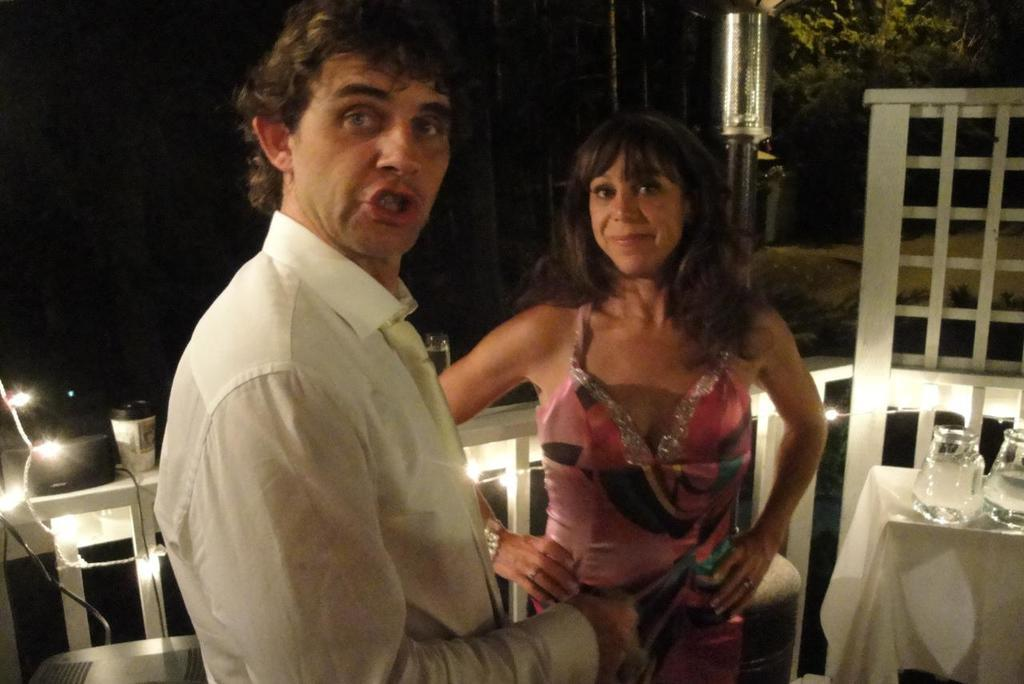What is the gender of the person in the image? There is a man in the image. What is the man doing in the image? The man is talking. What is the man wearing in the image? The man is wearing a white dress. Can you describe the woman in the image? There is a woman in the image, and she is standing. What is the woman wearing in the image? The woman is wearing a pink dress. What objects can be seen on the table in the image? There are wine glasses on a table in the image. How does the clam contribute to the pollution in the image? There is no clam present in the image, and therefore it cannot contribute to any pollution. 